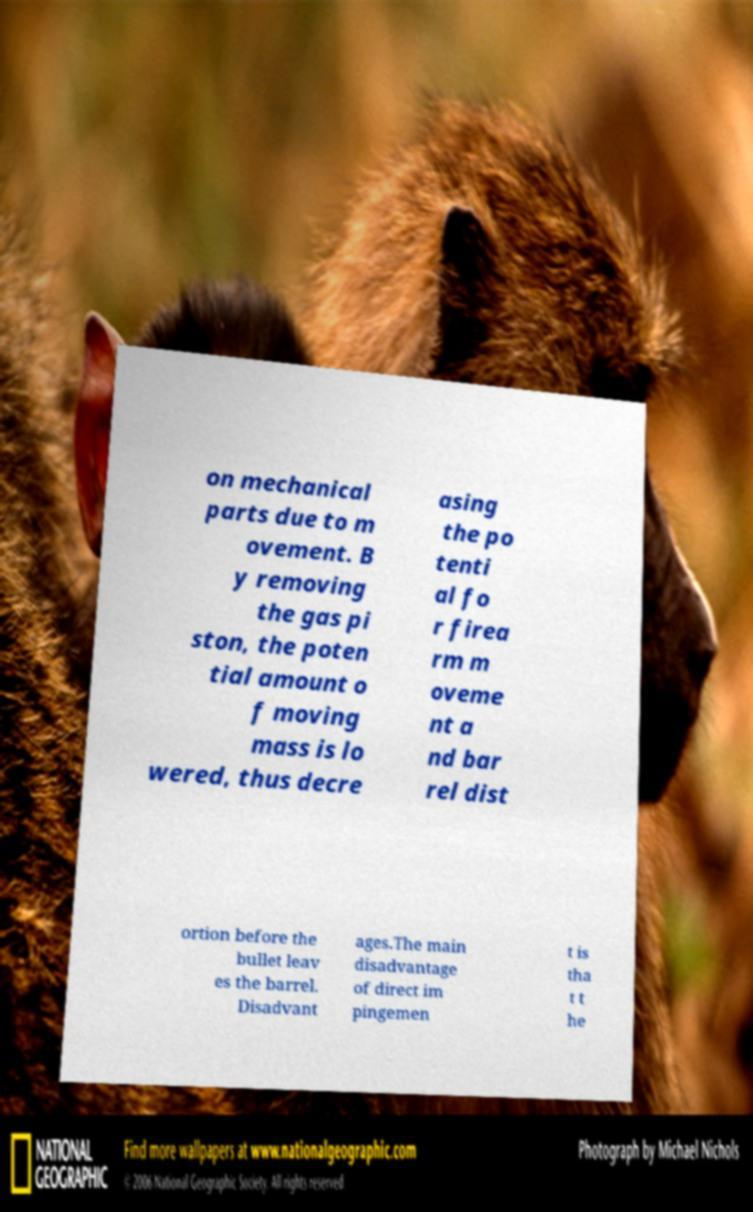Please identify and transcribe the text found in this image. on mechanical parts due to m ovement. B y removing the gas pi ston, the poten tial amount o f moving mass is lo wered, thus decre asing the po tenti al fo r firea rm m oveme nt a nd bar rel dist ortion before the bullet leav es the barrel. Disadvant ages.The main disadvantage of direct im pingemen t is tha t t he 